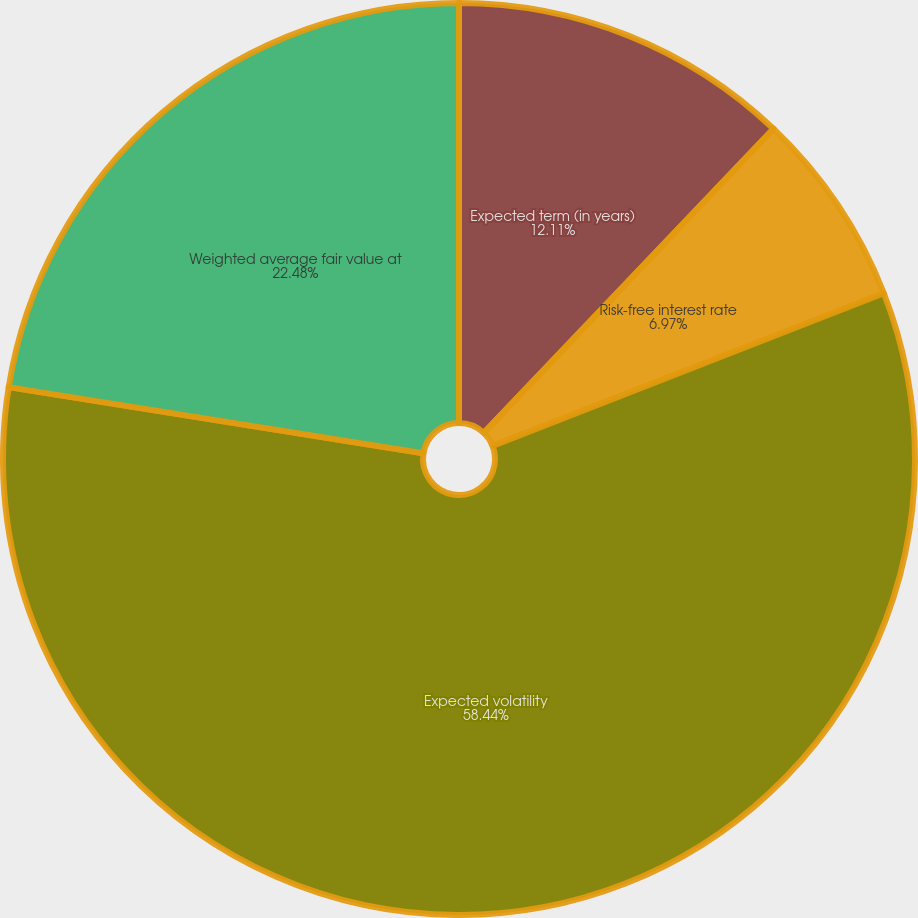<chart> <loc_0><loc_0><loc_500><loc_500><pie_chart><fcel>Expected term (in years)<fcel>Risk-free interest rate<fcel>Expected volatility<fcel>Weighted average fair value at<nl><fcel>12.11%<fcel>6.97%<fcel>58.44%<fcel>22.48%<nl></chart> 